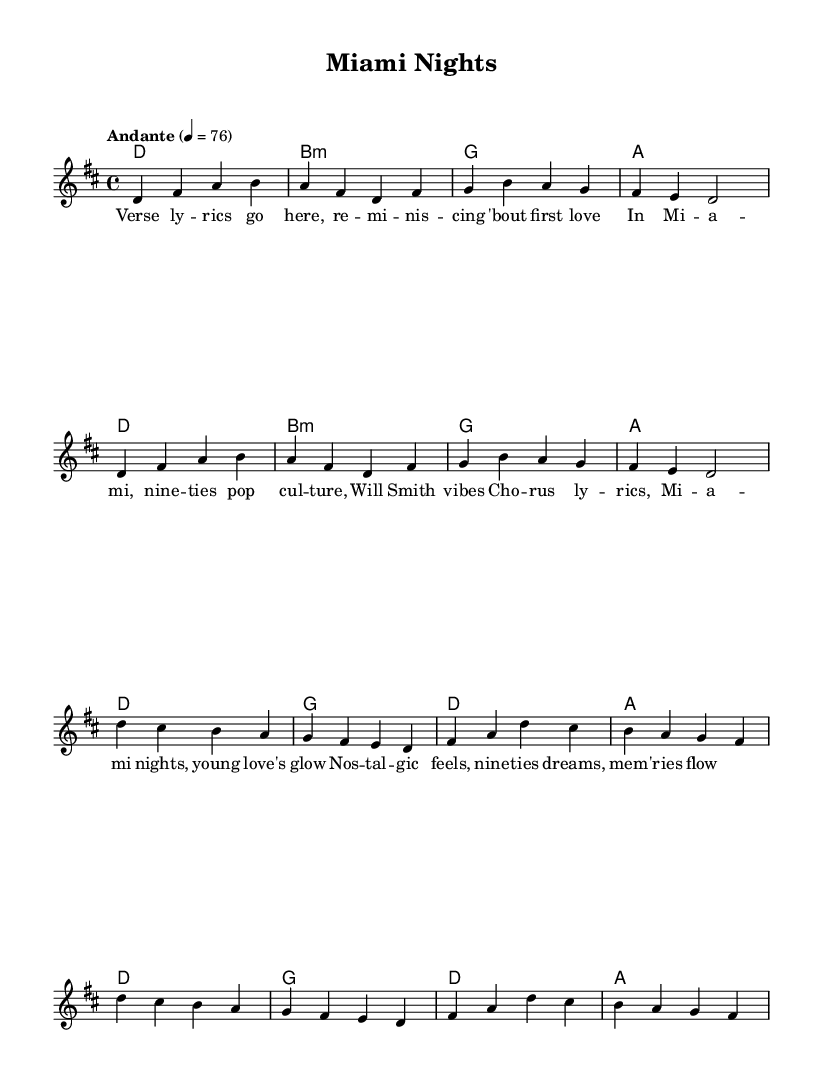What is the key signature of this music? The key signature is D major, which has two sharps (F# and C#). This can be identified by looking at the key signature shown at the beginning of the sheet music.
Answer: D major What is the time signature of this music? The time signature is 4/4, indicated at the beginning of the piece. This means there are four beats in each measure, and a quarter note receives one beat.
Answer: 4/4 What is the tempo marking of the piece? The tempo marking is "Andante," which indicates a moderate pace. This is found in the tempo indication at the start of the piece, specifying the desired speed of play.
Answer: Andante How many measures are in the verse section? There are eight measures in the verse section, which can be counted by looking at the melody and harmonies outlined under the 'Verse' header.
Answer: Eight What is the last chord of the chorus? The last chord of the chorus is A major, which can be checked by locating the final chord in the chord progression written under the 'Chorus' section.
Answer: A major Which lyrical theme is expressed in the verse lyrics? The verse lyrics express nostalgia for first love and reference 1990s pop culture. By analyzing the lyrics, one can identify themes of reminiscence and youthful experiences.
Answer: Nostalgia What is the feeling conveyed by the song's melody and lyrics combined? The song conveys a feeling of warmth and reminiscence about young love through both the sweet, flowing melody in D major and the reflective lyrics about Miami nights and the past.
Answer: Warmth 